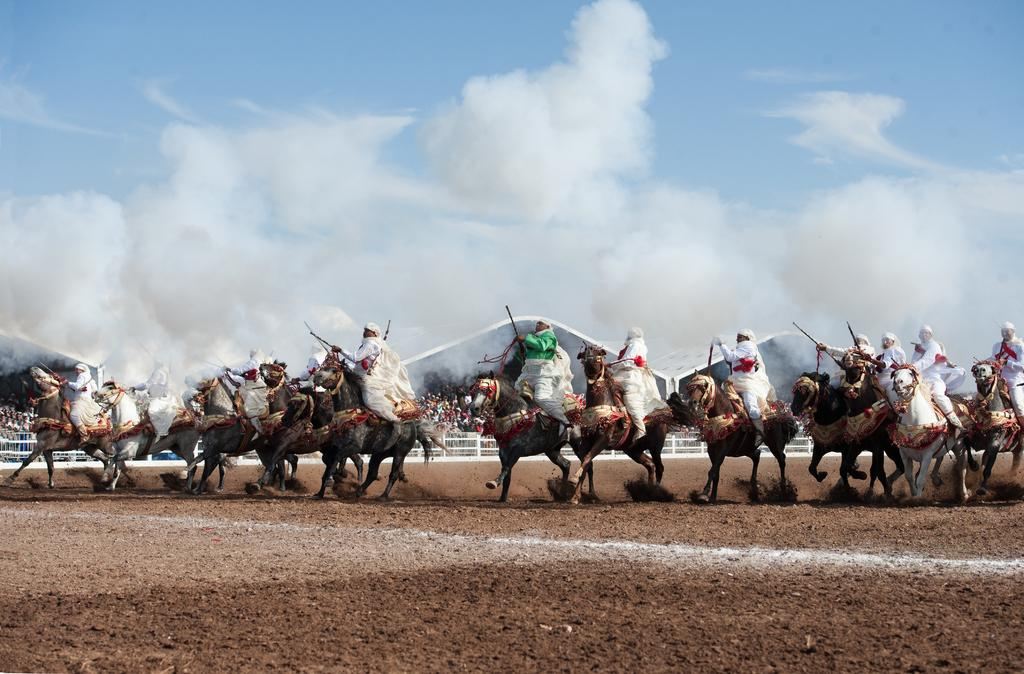What are the people in the image doing? The people in the image are riding horses. Where are the horses located? The horses are on the ground. Can you describe the background of the image? In the background of the image, there are people, a fence, shelters, and a cloudy sky. What type of yak can be seen in the image? There is no yak present in the image; it features people riding horses. What route are the people on horseback taking in the image? The image does not provide information about the route the people on horseback are taking. 